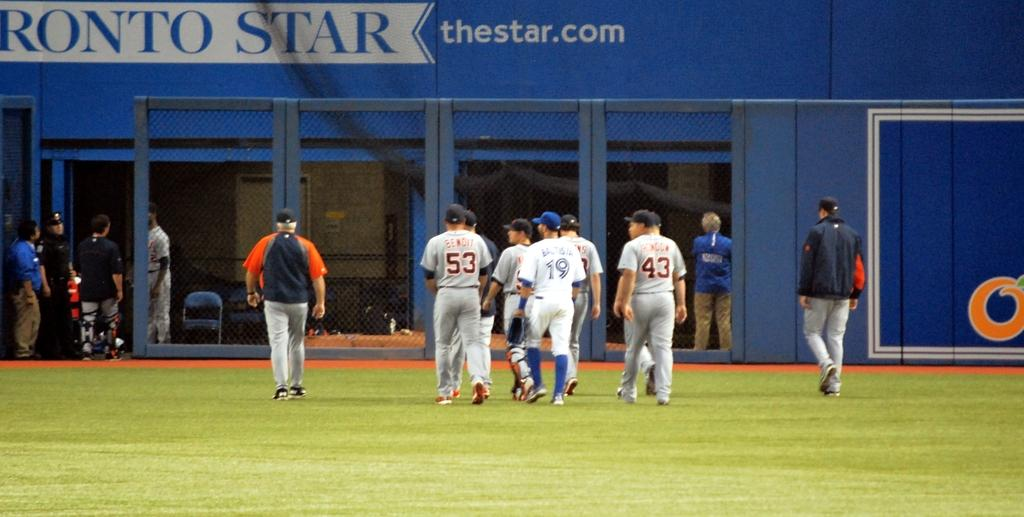<image>
Give a short and clear explanation of the subsequent image. A group of baseball players including Benoit and Bautista talking in the outfield. 